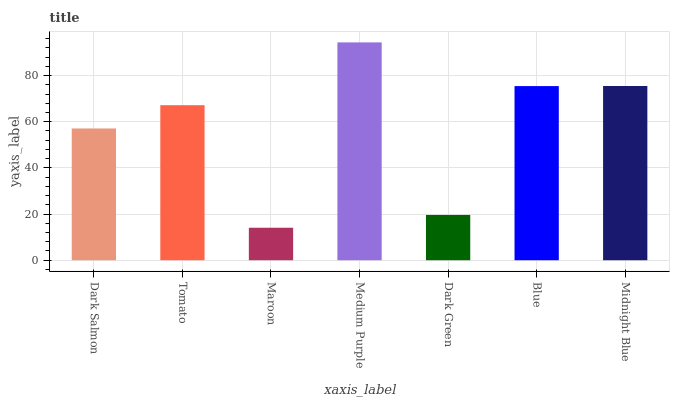Is Maroon the minimum?
Answer yes or no. Yes. Is Medium Purple the maximum?
Answer yes or no. Yes. Is Tomato the minimum?
Answer yes or no. No. Is Tomato the maximum?
Answer yes or no. No. Is Tomato greater than Dark Salmon?
Answer yes or no. Yes. Is Dark Salmon less than Tomato?
Answer yes or no. Yes. Is Dark Salmon greater than Tomato?
Answer yes or no. No. Is Tomato less than Dark Salmon?
Answer yes or no. No. Is Tomato the high median?
Answer yes or no. Yes. Is Tomato the low median?
Answer yes or no. Yes. Is Midnight Blue the high median?
Answer yes or no. No. Is Maroon the low median?
Answer yes or no. No. 